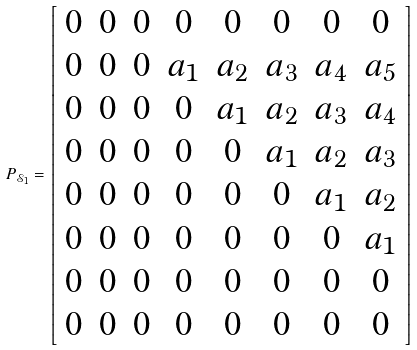<formula> <loc_0><loc_0><loc_500><loc_500>P _ { \mathcal { S } _ { 1 } } = \left [ \begin{array} { c c c c c c c c } 0 & 0 & 0 & 0 & 0 & 0 & 0 & 0 \\ 0 & 0 & 0 & a _ { 1 } & a _ { 2 } & a _ { 3 } & a _ { 4 } & a _ { 5 } \\ 0 & 0 & 0 & 0 & a _ { 1 } & a _ { 2 } & a _ { 3 } & a _ { 4 } \\ 0 & 0 & 0 & 0 & 0 & a _ { 1 } & a _ { 2 } & a _ { 3 } \\ 0 & 0 & 0 & 0 & 0 & 0 & a _ { 1 } & a _ { 2 } \\ 0 & 0 & 0 & 0 & 0 & 0 & 0 & a _ { 1 } \\ 0 & 0 & 0 & 0 & 0 & 0 & 0 & 0 \\ 0 & 0 & 0 & 0 & 0 & 0 & 0 & 0 \end{array} \right ]</formula> 